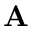<formula> <loc_0><loc_0><loc_500><loc_500>{ A }</formula> 